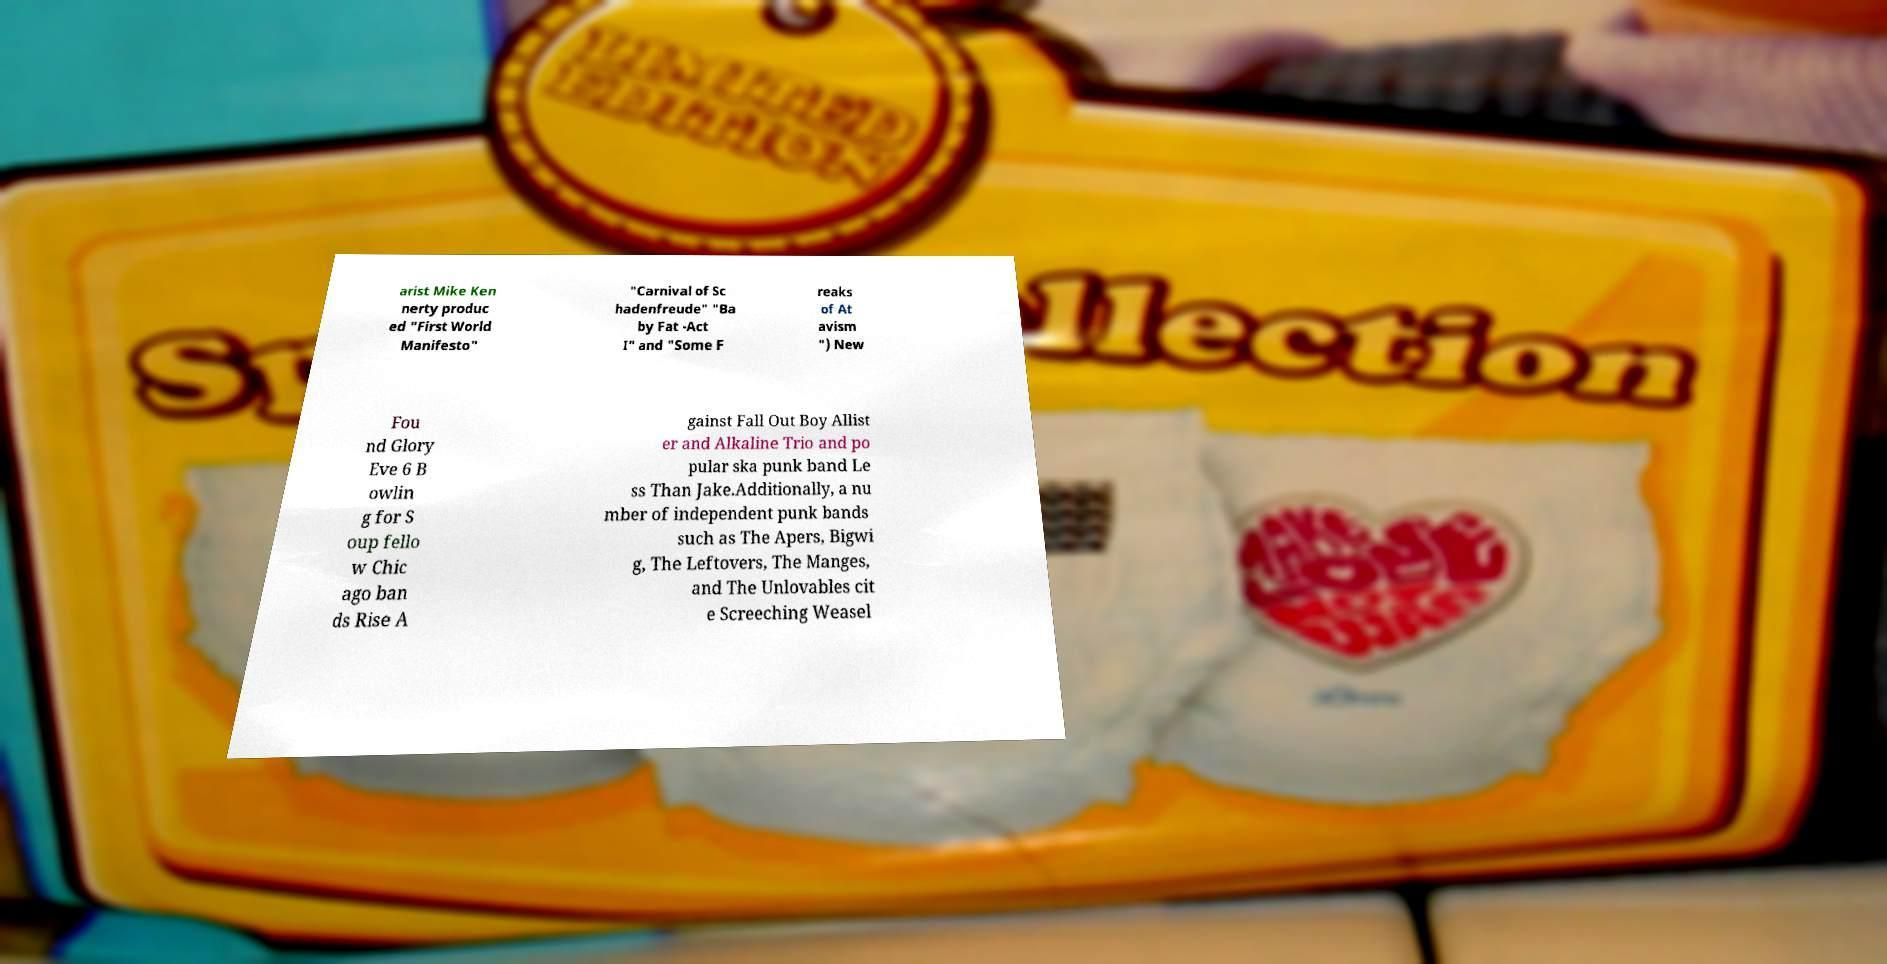There's text embedded in this image that I need extracted. Can you transcribe it verbatim? arist Mike Ken nerty produc ed "First World Manifesto" "Carnival of Sc hadenfreude" "Ba by Fat -Act I" and "Some F reaks of At avism ") New Fou nd Glory Eve 6 B owlin g for S oup fello w Chic ago ban ds Rise A gainst Fall Out Boy Allist er and Alkaline Trio and po pular ska punk band Le ss Than Jake.Additionally, a nu mber of independent punk bands such as The Apers, Bigwi g, The Leftovers, The Manges, and The Unlovables cit e Screeching Weasel 